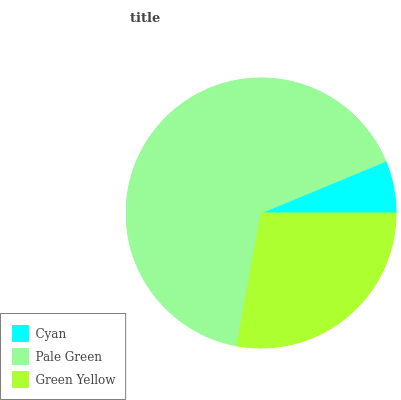Is Cyan the minimum?
Answer yes or no. Yes. Is Pale Green the maximum?
Answer yes or no. Yes. Is Green Yellow the minimum?
Answer yes or no. No. Is Green Yellow the maximum?
Answer yes or no. No. Is Pale Green greater than Green Yellow?
Answer yes or no. Yes. Is Green Yellow less than Pale Green?
Answer yes or no. Yes. Is Green Yellow greater than Pale Green?
Answer yes or no. No. Is Pale Green less than Green Yellow?
Answer yes or no. No. Is Green Yellow the high median?
Answer yes or no. Yes. Is Green Yellow the low median?
Answer yes or no. Yes. Is Cyan the high median?
Answer yes or no. No. Is Pale Green the low median?
Answer yes or no. No. 